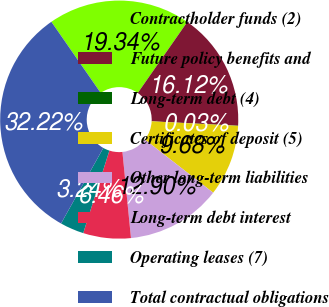Convert chart to OTSL. <chart><loc_0><loc_0><loc_500><loc_500><pie_chart><fcel>Contractholder funds (2)<fcel>Future policy benefits and<fcel>Long-term debt (4)<fcel>Certificates of deposit (5)<fcel>Other long-term liabilities<fcel>Long-term debt interest<fcel>Operating leases (7)<fcel>Total contractual obligations<nl><fcel>19.34%<fcel>16.12%<fcel>0.03%<fcel>9.68%<fcel>12.9%<fcel>6.46%<fcel>3.24%<fcel>32.22%<nl></chart> 